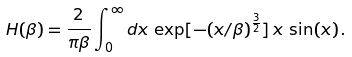Convert formula to latex. <formula><loc_0><loc_0><loc_500><loc_500>H ( \beta ) = \frac { 2 } { \pi \beta } \int _ { 0 } ^ { \infty } d x \, \exp [ - ( x / \beta ) ^ { \frac { 3 } { 2 } } ] \, x \, \sin ( x ) \, .</formula> 